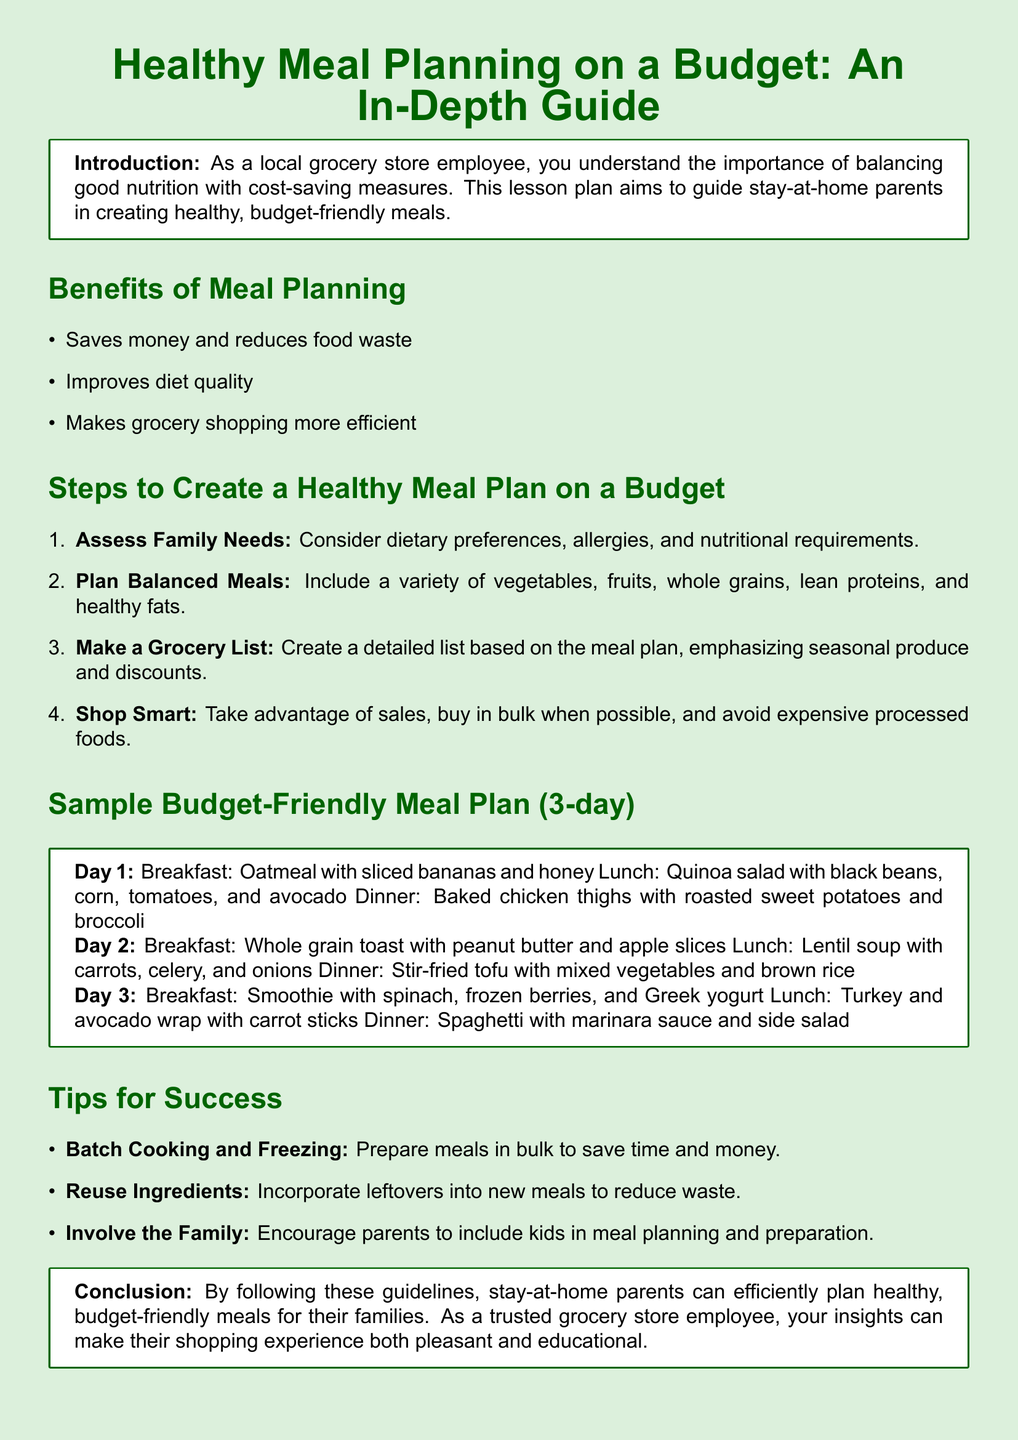What is the main topic of the document? The document is titled "Healthy Meal Planning on a Budget: An In-Depth Guide," indicating its focus.
Answer: Healthy Meal Planning on a Budget What is one benefit of meal planning mentioned? The document lists benefits, including saving money and reducing food waste, as one of the reasons for meal planning.
Answer: Saves money and reduces food waste How many days does the sample meal plan cover? The sample meal plan outlined in the document specifies meal options for three consecutive days.
Answer: 3 days What is one tip for success in meal planning? The document provides practical tips, such as batch cooking and freezing, for effective meal planning.
Answer: Batch Cooking and Freezing Which food is included in Day 2's breakfast? The meal plan's Day 2 breakfast consists of whole grain toast, peanut butter, and apple slices as per the document's details.
Answer: Whole grain toast with peanut butter and apple slices What is emphasized when creating a grocery list? The document highlights the importance of focusing on seasonal produce and discounts when making grocery lists.
Answer: Seasonal produce and discounts What should be included in balanced meals? The document specifies that balanced meals should consist of a variety of vegetables, fruits, whole grains, lean proteins, and healthy fats.
Answer: Variety of vegetables, fruits, whole grains, lean proteins, and healthy fats What is the purpose of this lesson plan? The document describes its purpose as guiding stay-at-home parents in creating healthy, budget-friendly meals.
Answer: Guiding stay-at-home parents in creating healthy, budget-friendly meals 